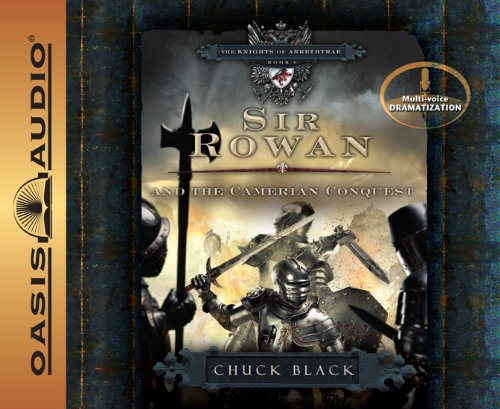Is this book related to Parenting & Relationships? No, this book is not related to the Parenting & Relationships genre. It is primarily focused on adventurous and fantastical themes appropriate for young adult readers. 